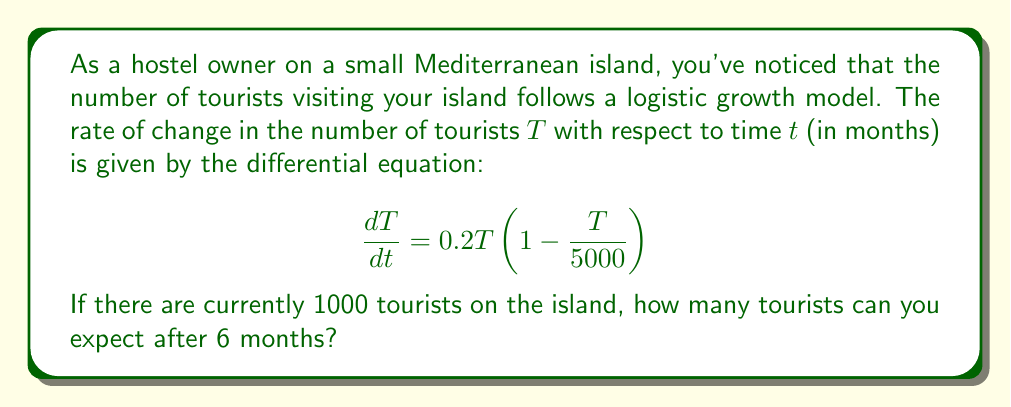Can you solve this math problem? To solve this problem, we need to use the logistic differential equation and its solution. Let's approach this step-by-step:

1) The given differential equation is in the form of the logistic growth model:

   $$\frac{dT}{dt} = rT(1 - \frac{T}{K})$$

   where $r = 0.2$ is the growth rate and $K = 5000$ is the carrying capacity.

2) The solution to the logistic differential equation is:

   $$T(t) = \frac{K}{1 + (\frac{K}{T_0} - 1)e^{-rt}}$$

   where $T_0$ is the initial population.

3) We're given that $T_0 = 1000$, $K = 5000$, $r = 0.2$, and we need to find $T(6)$.

4) Substituting these values into the solution:

   $$T(6) = \frac{5000}{1 + (\frac{5000}{1000} - 1)e^{-0.2(6)}}$$

5) Simplify:
   
   $$T(6) = \frac{5000}{1 + 4e^{-1.2}}$$

6) Calculate:
   
   $$T(6) = \frac{5000}{1 + 4(0.301194...)} \approx 2987.44$$

Therefore, after 6 months, you can expect approximately 2987 tourists on the island.
Answer: 2987 tourists (rounded to the nearest whole number) 